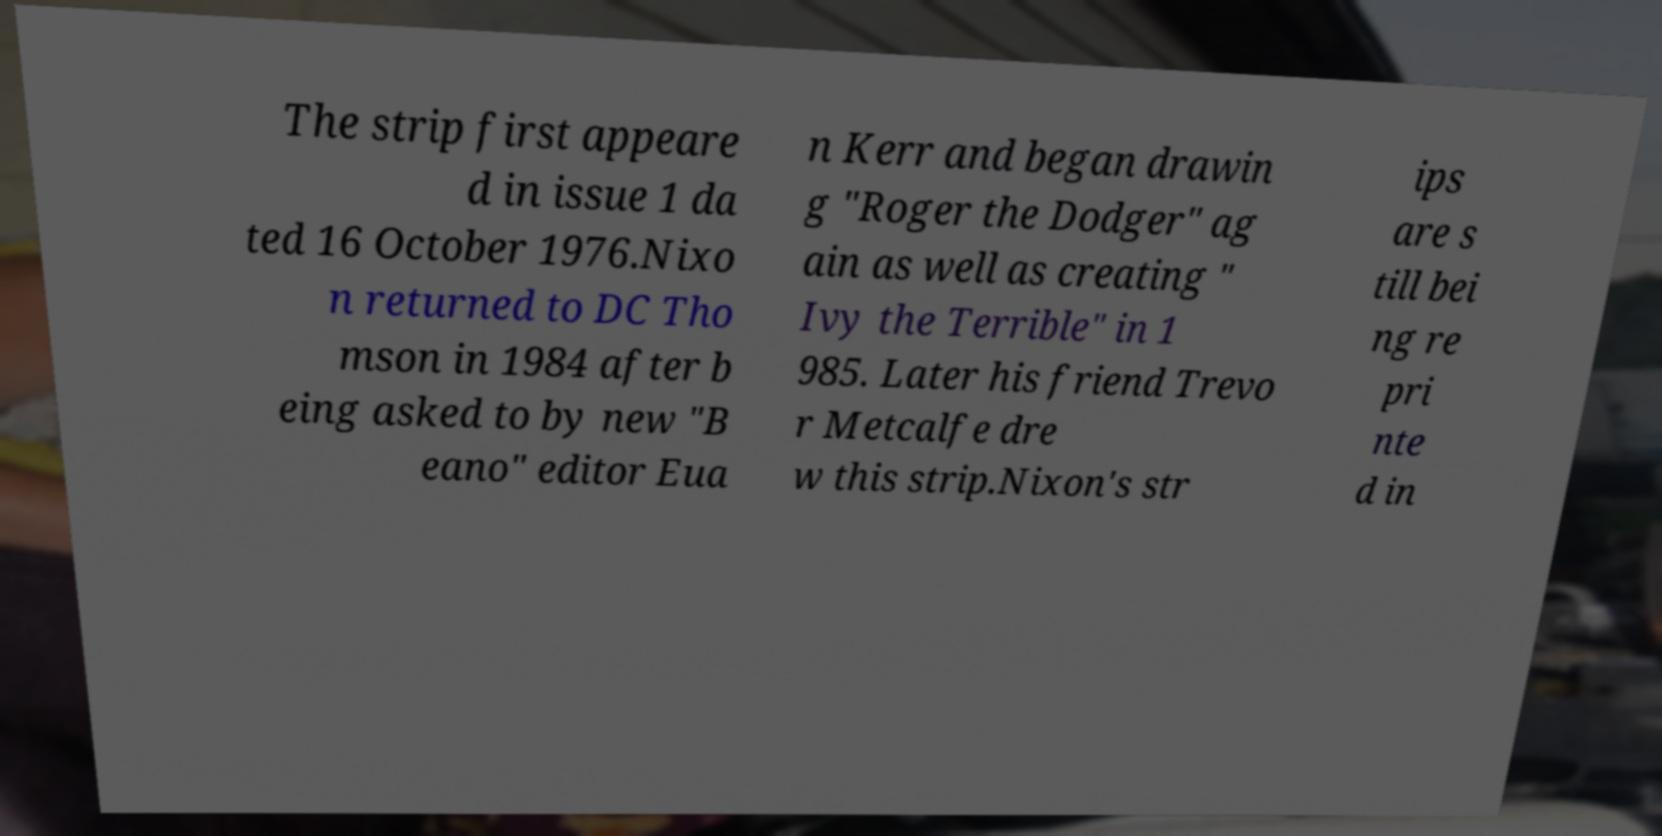There's text embedded in this image that I need extracted. Can you transcribe it verbatim? The strip first appeare d in issue 1 da ted 16 October 1976.Nixo n returned to DC Tho mson in 1984 after b eing asked to by new "B eano" editor Eua n Kerr and began drawin g "Roger the Dodger" ag ain as well as creating " Ivy the Terrible" in 1 985. Later his friend Trevo r Metcalfe dre w this strip.Nixon's str ips are s till bei ng re pri nte d in 